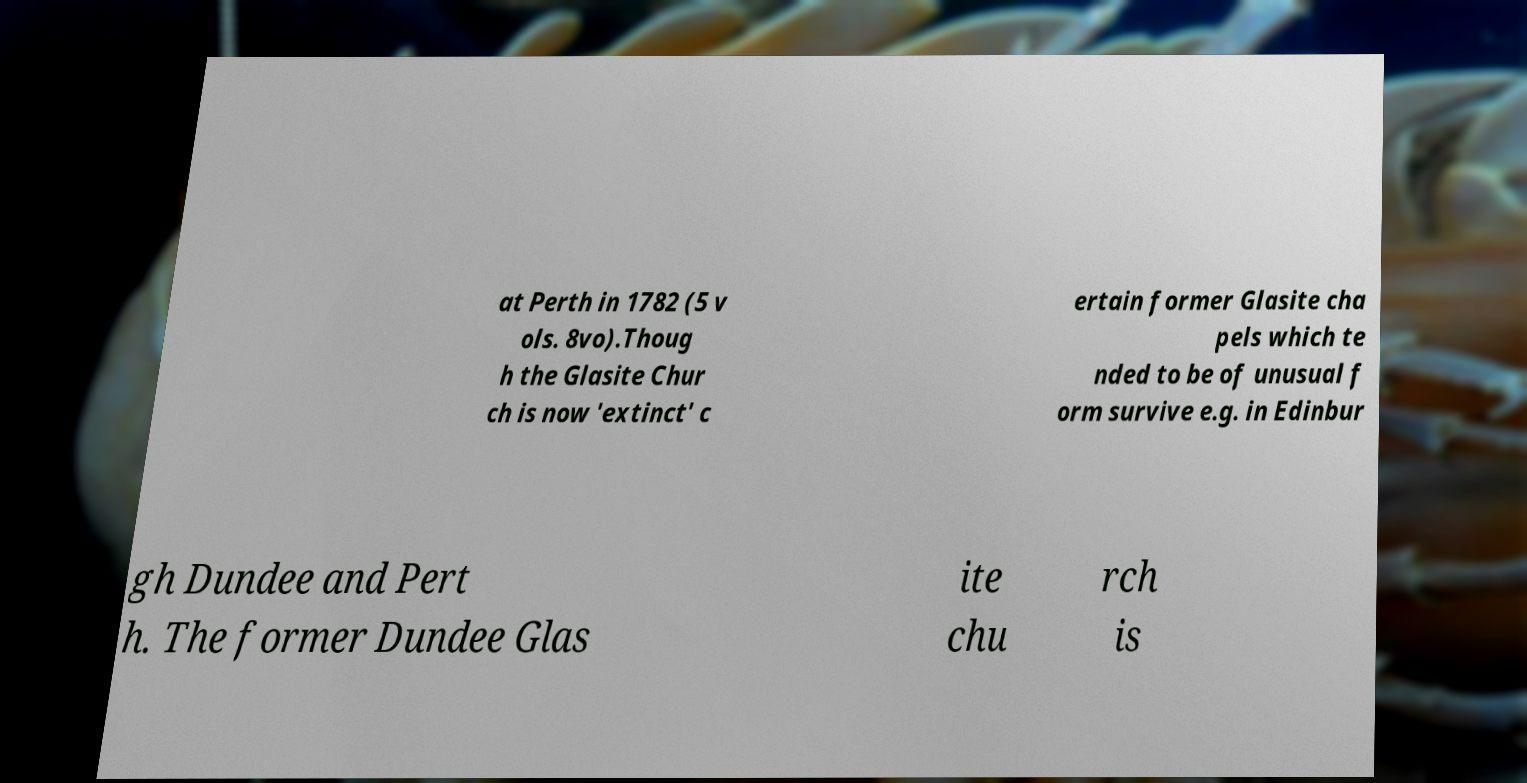For documentation purposes, I need the text within this image transcribed. Could you provide that? at Perth in 1782 (5 v ols. 8vo).Thoug h the Glasite Chur ch is now 'extinct' c ertain former Glasite cha pels which te nded to be of unusual f orm survive e.g. in Edinbur gh Dundee and Pert h. The former Dundee Glas ite chu rch is 